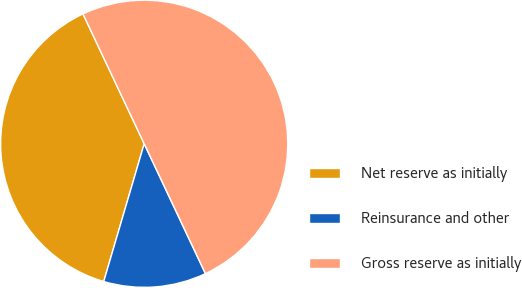Convert chart to OTSL. <chart><loc_0><loc_0><loc_500><loc_500><pie_chart><fcel>Net reserve as initially<fcel>Reinsurance and other<fcel>Gross reserve as initially<nl><fcel>38.44%<fcel>11.56%<fcel>50.0%<nl></chart> 